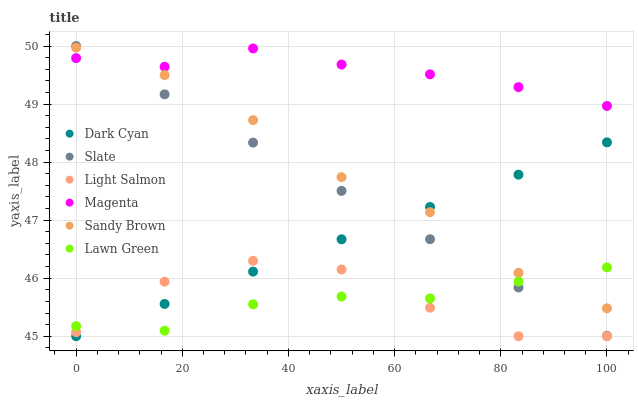Does Lawn Green have the minimum area under the curve?
Answer yes or no. Yes. Does Magenta have the maximum area under the curve?
Answer yes or no. Yes. Does Light Salmon have the minimum area under the curve?
Answer yes or no. No. Does Light Salmon have the maximum area under the curve?
Answer yes or no. No. Is Dark Cyan the smoothest?
Answer yes or no. Yes. Is Light Salmon the roughest?
Answer yes or no. Yes. Is Slate the smoothest?
Answer yes or no. No. Is Slate the roughest?
Answer yes or no. No. Does Light Salmon have the lowest value?
Answer yes or no. Yes. Does Slate have the lowest value?
Answer yes or no. No. Does Slate have the highest value?
Answer yes or no. Yes. Does Light Salmon have the highest value?
Answer yes or no. No. Is Lawn Green less than Magenta?
Answer yes or no. Yes. Is Slate greater than Light Salmon?
Answer yes or no. Yes. Does Light Salmon intersect Lawn Green?
Answer yes or no. Yes. Is Light Salmon less than Lawn Green?
Answer yes or no. No. Is Light Salmon greater than Lawn Green?
Answer yes or no. No. Does Lawn Green intersect Magenta?
Answer yes or no. No. 